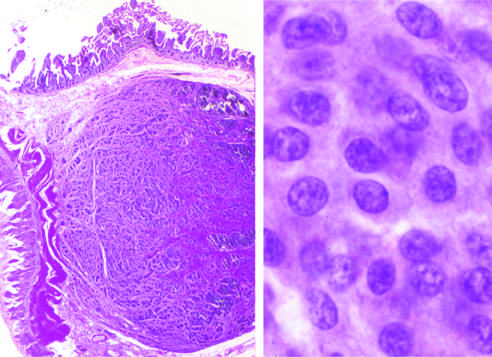what is the appearance of the chromatin texture, with fine and coarse clumps?
Answer the question using a single word or phrase. A salt-and-pepper pattern 